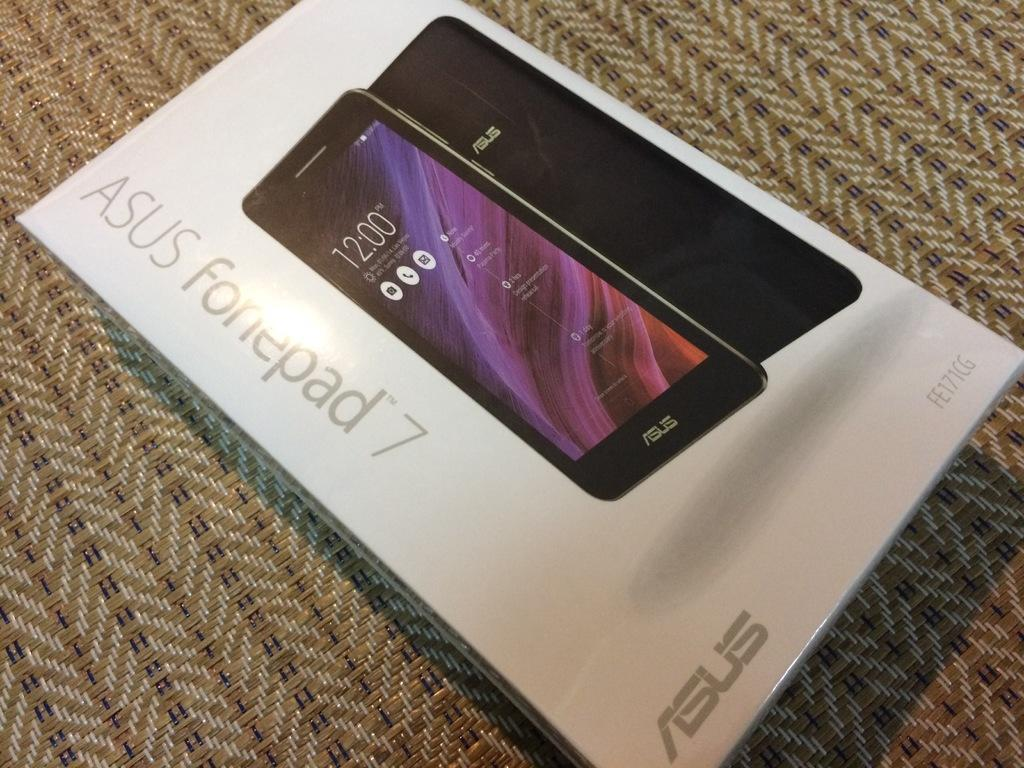Provide a one-sentence caption for the provided image. A box of a Asus Fonepad 7 laying on a carpet. 